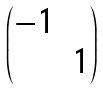Convert formula to latex. <formula><loc_0><loc_0><loc_500><loc_500>\begin{pmatrix} - 1 \\ & 1 \end{pmatrix}</formula> 